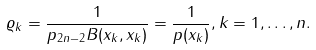Convert formula to latex. <formula><loc_0><loc_0><loc_500><loc_500>{ \varrho _ { k } } = \frac { 1 } { p _ { 2 n - 2 } B ( x _ { k } , x _ { k } ) } = \frac { 1 } { p ( x _ { k } ) } , k = 1 , \dots , n .</formula> 